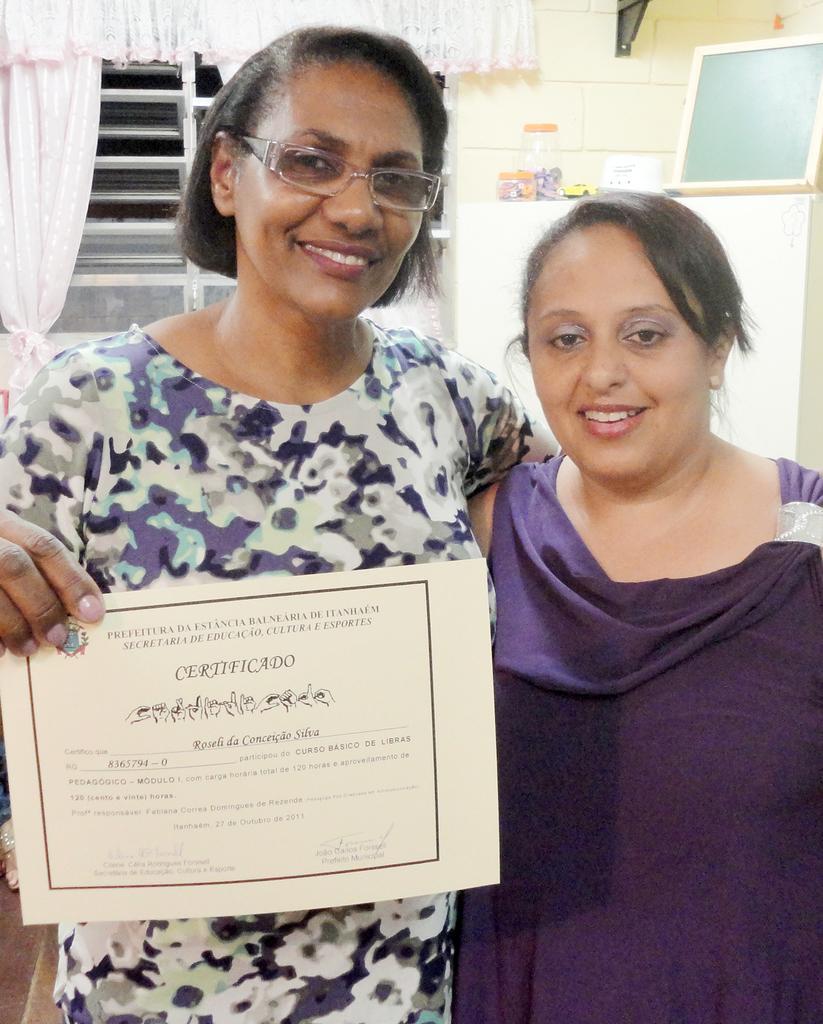Please provide a concise description of this image. In this image there are two persons standing and smiling ,a person holding a certificate, and in the background there is a board and boxes on the object, window, curtains. 